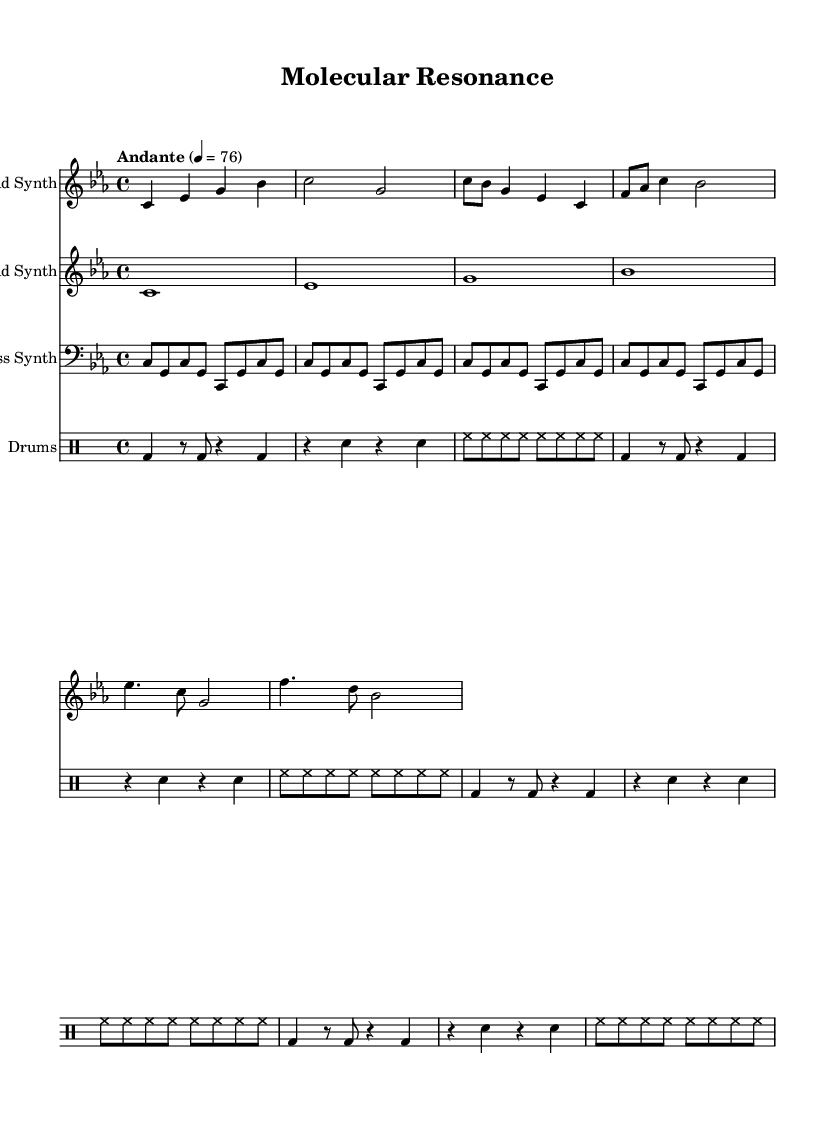What is the key signature of this music? The key signature is C minor, which contains three flats (B flat, E flat, and A flat). This is indicated at the beginning of the music.
Answer: C minor What is the time signature of this music? The time signature is 4/4, which means there are four beats in each measure. This is shown at the beginning of the score, before the musical notes.
Answer: 4/4 What is the tempo marking given in the music? The tempo marking is "Andante," which describes the pace of the piece as moderately slow. It is followed by a metronome marking of 76 beats per minute.
Answer: Andante What instrument plays the lead part in this piece? The lead part is labeled "Lead Synth," indicating that a synthesizer is used for the melody in this composition. It is specified in the staff name at the beginning of the lead part.
Answer: Lead Synth Which section of the music has the highest pitch notes? The "Lead Synth" section has the highest pitch notes, which can be determined by examining the range of notes played in each staff. The lead part features notes like C and E flat that are higher than those in the bass part.
Answer: Lead Synth How many measures are in the bass synth part? The bass synth part comprises a total of 8 measures, as the containing notes are placed in 8 individual segments framed by bar lines in the score.
Answer: 8 measures What characterizes the rhythm of the drums part in this piece? The rhythm of the drums part includes a combination of bass drum, snare drum, and hi-hat, with a repeating pattern that adds a steady pulse throughout the piece. This is evident from the rhythmic notations appearing consistently per measure.
Answer: Steady pulse 